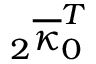<formula> <loc_0><loc_0><loc_500><loc_500>{ } _ { 2 } \overline { \kappa } _ { 0 } ^ { T }</formula> 